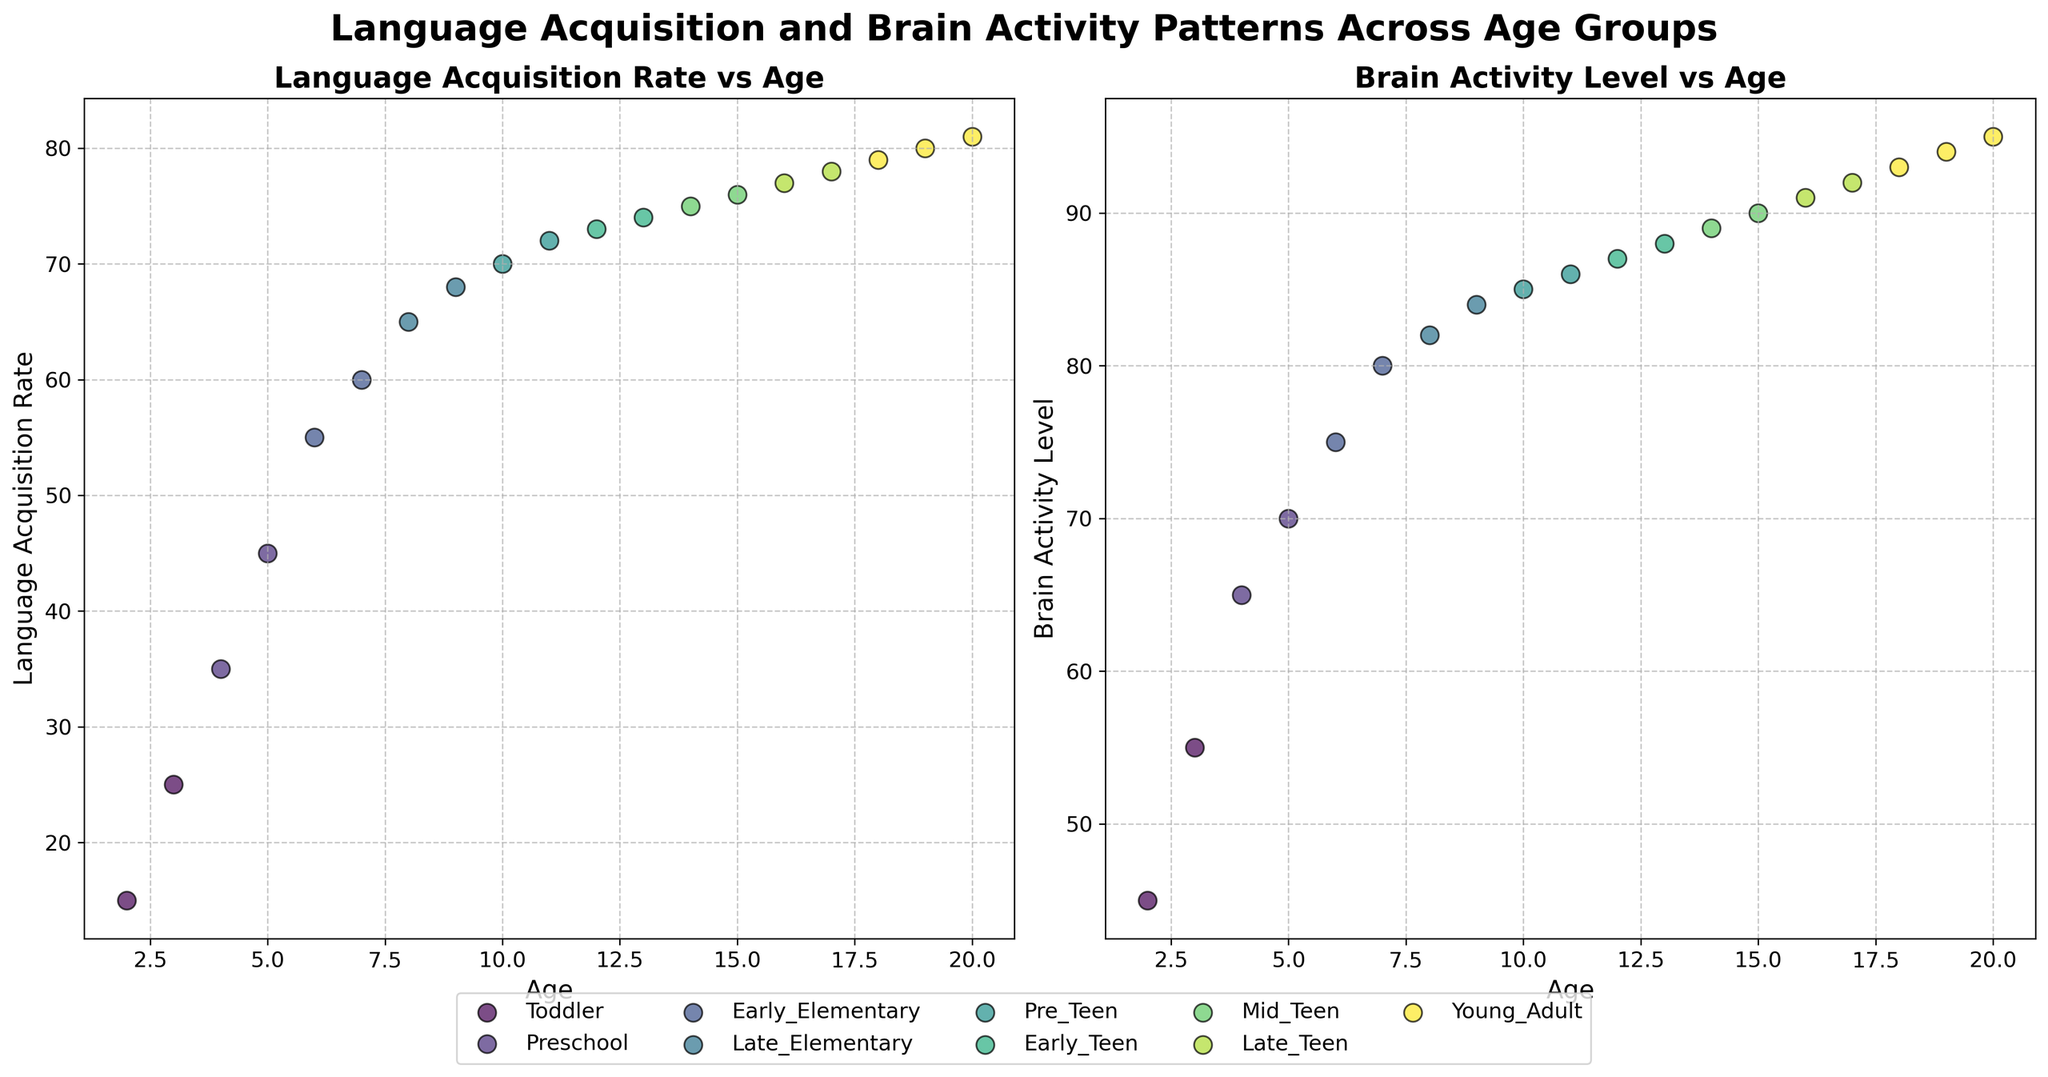Who is the target audience for this figure? The title and axes labels indicate that the figure compares language acquisition rates and brain activity patterns across different age groups, suggesting it targets researchers or educators interested in child development and cognitive neuroscience.
Answer: Researchers/Educators interested in child development What are the titles of the two subplots? The titles of the two subplots are "Language Acquisition Rate vs Age" and "Brain Activity Level vs Age".
Answer: "Language Acquisition Rate vs Age" and "Brain Activity Level vs Age" Which age group has the highest language acquisition rate? The "Young_Adult" age group, which includes ages 18-20, has the highest language acquisition rate, reaching a rate of 81 at age 20.
Answer: Young_Adult How does brain activity level change from age 2 to age 20? Brain activity level steadily increases from age 2 to age 20. It starts at 45 for toddlers and reaches 95 for young adults.
Answer: Increases steadily What is the color used to represent the "Early_Teen" age group? The "Early_Teen" age group is represented by a specific shade of color, which can be identified in the color legend in the plot.
Answer: Check the legend Which age group shows the greatest increase in brain activity level? By examining the differences in brain activity levels across groups, the Preschool age group shows a significant jump from 65 to 70.
Answer: Preschool At what age does language acquisition rate start to plateau? From roughly age 14 (Mid_Teen group) onward, the language acquisition rate exhibits smaller increments, suggesting a plateau.
Answer: Around age 14 In which subplot is the grid style described? Both subplots use a grid style described as "True, linestyle='--', alpha=0.7".
Answer: Both subplots What is the relationship between language acquisition rate and brain activity level in Early_Elementary age group? In the Early_Elementary age group, the language acquisition rate and brain activity level both steadily increase, where the acquisition rate goes from 55 to 60 and the brain activity level goes from 75 to 80.
Answer: Both increase steadily Given the pattern, at what age can we expect brain activity to reach 80 in a child? Brain activity level reaches 80 at age 7, which corresponds to the Early_Elementary age group.
Answer: Age 7 Which age group has the smallest range in brain activity levels? The Late_Teen age group (ages 16-17) has brain activity levels between 91 and 92, showcasing the smallest range.
Answer: Late_Teen 